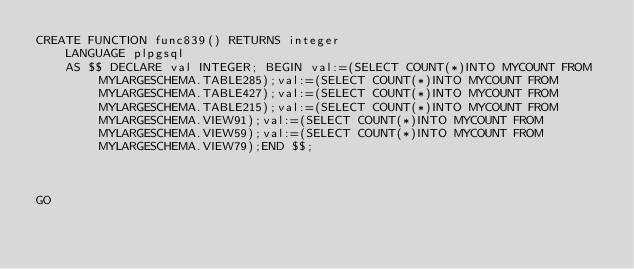Convert code to text. <code><loc_0><loc_0><loc_500><loc_500><_SQL_>CREATE FUNCTION func839() RETURNS integer
    LANGUAGE plpgsql
    AS $$ DECLARE val INTEGER; BEGIN val:=(SELECT COUNT(*)INTO MYCOUNT FROM MYLARGESCHEMA.TABLE285);val:=(SELECT COUNT(*)INTO MYCOUNT FROM MYLARGESCHEMA.TABLE427);val:=(SELECT COUNT(*)INTO MYCOUNT FROM MYLARGESCHEMA.TABLE215);val:=(SELECT COUNT(*)INTO MYCOUNT FROM MYLARGESCHEMA.VIEW91);val:=(SELECT COUNT(*)INTO MYCOUNT FROM MYLARGESCHEMA.VIEW59);val:=(SELECT COUNT(*)INTO MYCOUNT FROM MYLARGESCHEMA.VIEW79);END $$;



GO</code> 